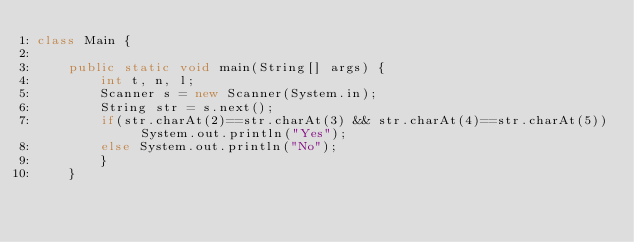<code> <loc_0><loc_0><loc_500><loc_500><_Java_>class Main {
 
    public static void main(String[] args) {
        int t, n, l;
        Scanner s = new Scanner(System.in);
        String str = s.next();
        if(str.charAt(2)==str.charAt(3) && str.charAt(4)==str.charAt(5)) System.out.println("Yes");
        else System.out.println("No");
        }
    }</code> 